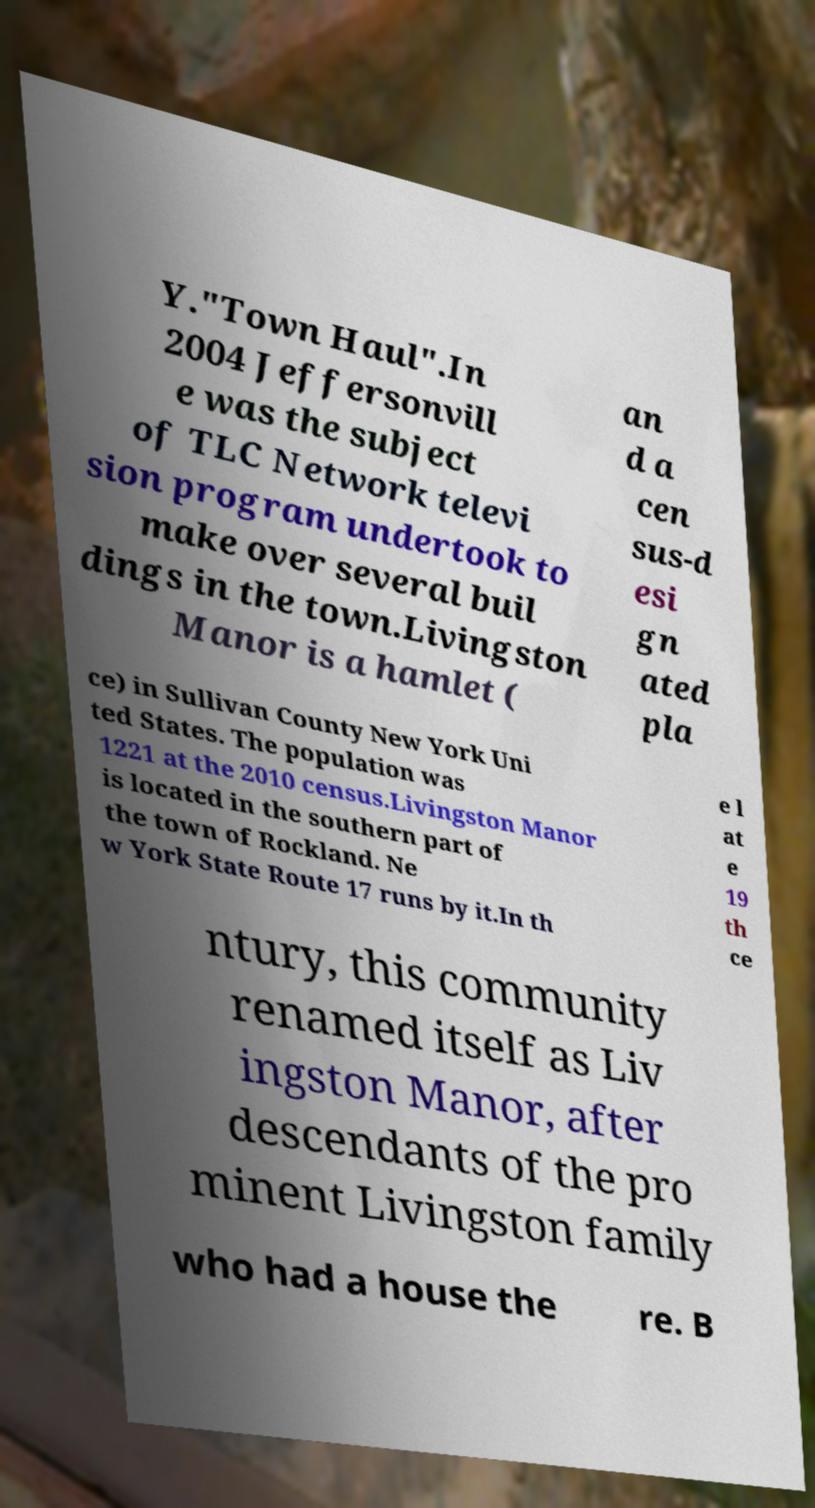Can you read and provide the text displayed in the image?This photo seems to have some interesting text. Can you extract and type it out for me? Y."Town Haul".In 2004 Jeffersonvill e was the subject of TLC Network televi sion program undertook to make over several buil dings in the town.Livingston Manor is a hamlet ( an d a cen sus-d esi gn ated pla ce) in Sullivan County New York Uni ted States. The population was 1221 at the 2010 census.Livingston Manor is located in the southern part of the town of Rockland. Ne w York State Route 17 runs by it.In th e l at e 19 th ce ntury, this community renamed itself as Liv ingston Manor, after descendants of the pro minent Livingston family who had a house the re. B 